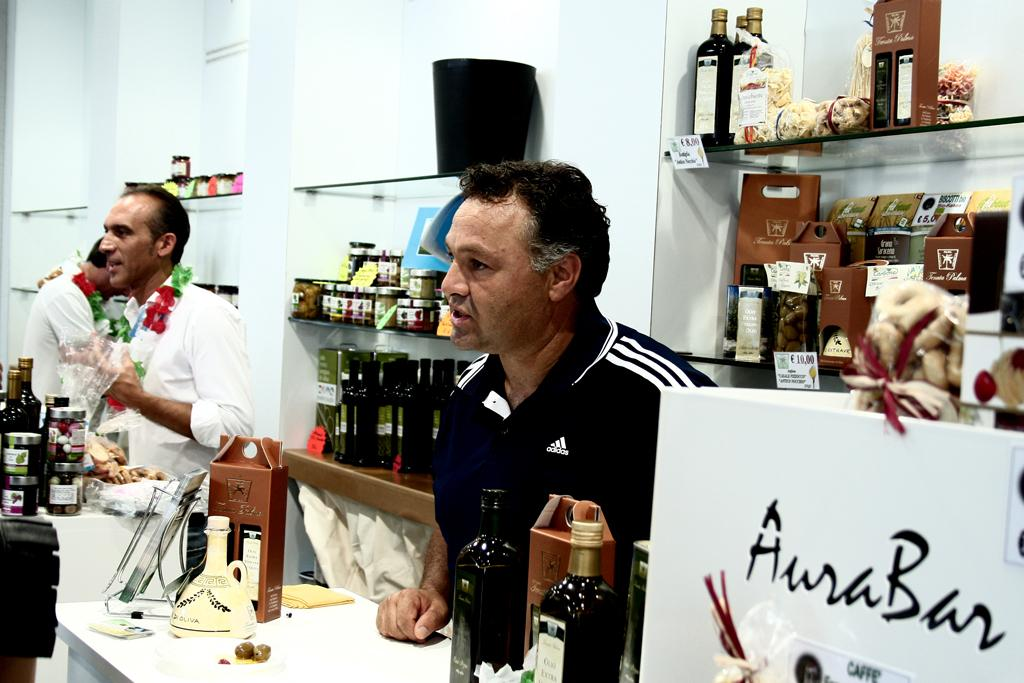Provide a one-sentence caption for the provided image. Men standing behind a counter looking at something off camera and there is a white box that says AuraBan on it. 